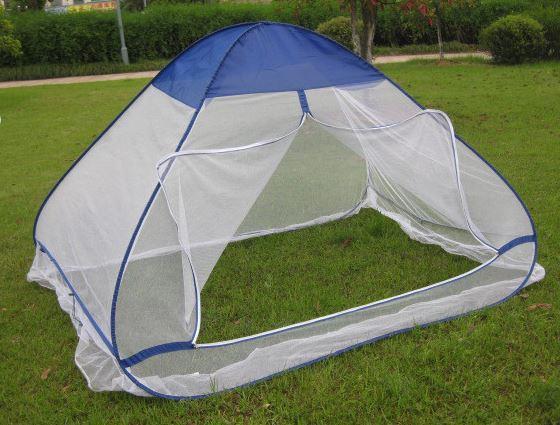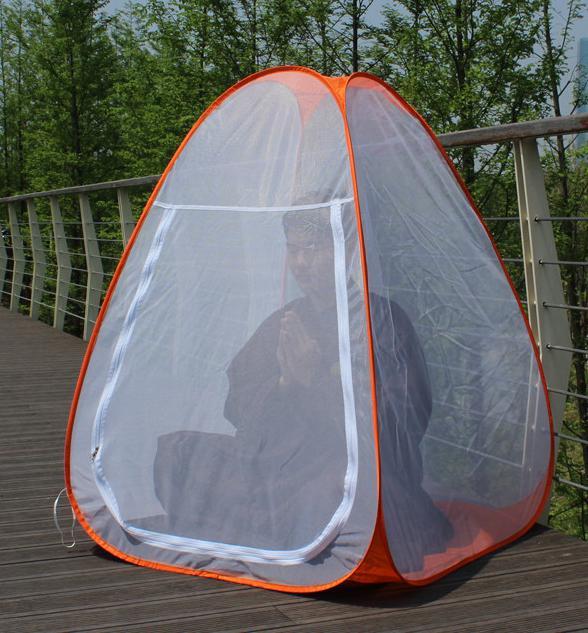The first image is the image on the left, the second image is the image on the right. Examine the images to the left and right. Is the description "there are two white pillows in the image on the left" accurate? Answer yes or no. No. The first image is the image on the left, the second image is the image on the right. For the images shown, is this caption "A canopy screen is sitting on bare grass with nothing under it." true? Answer yes or no. Yes. 